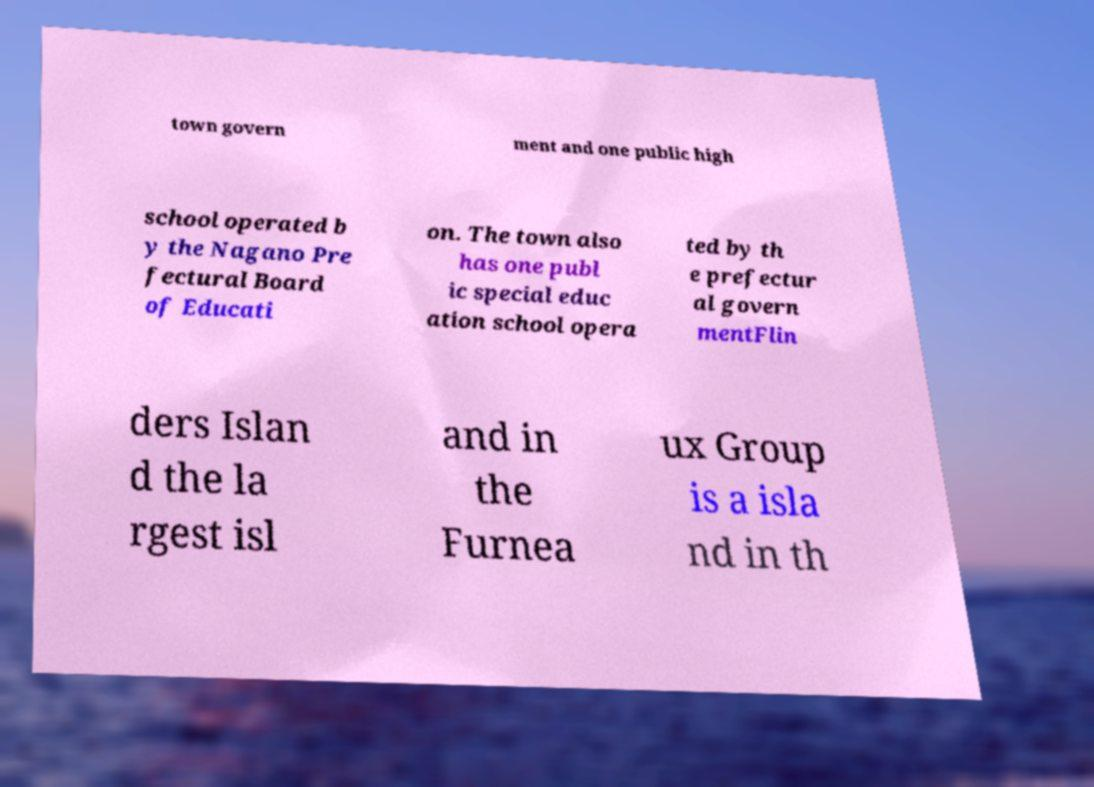Could you extract and type out the text from this image? town govern ment and one public high school operated b y the Nagano Pre fectural Board of Educati on. The town also has one publ ic special educ ation school opera ted by th e prefectur al govern mentFlin ders Islan d the la rgest isl and in the Furnea ux Group is a isla nd in th 